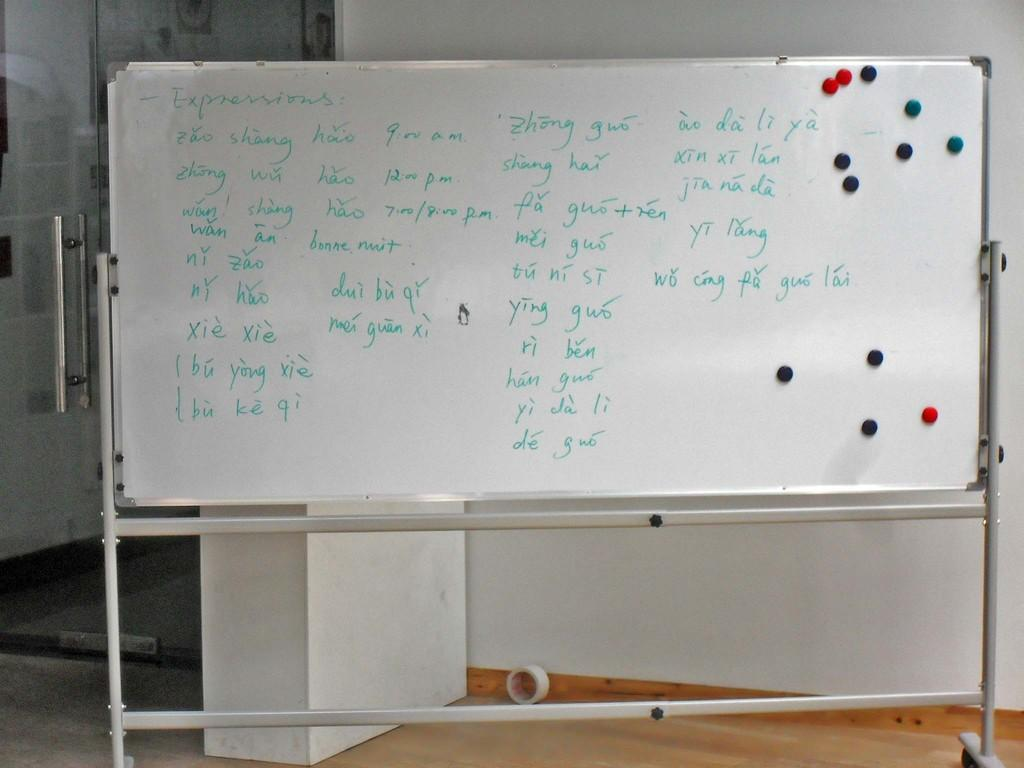<image>
Relay a brief, clear account of the picture shown. A white board is full of words identified as expressions. 